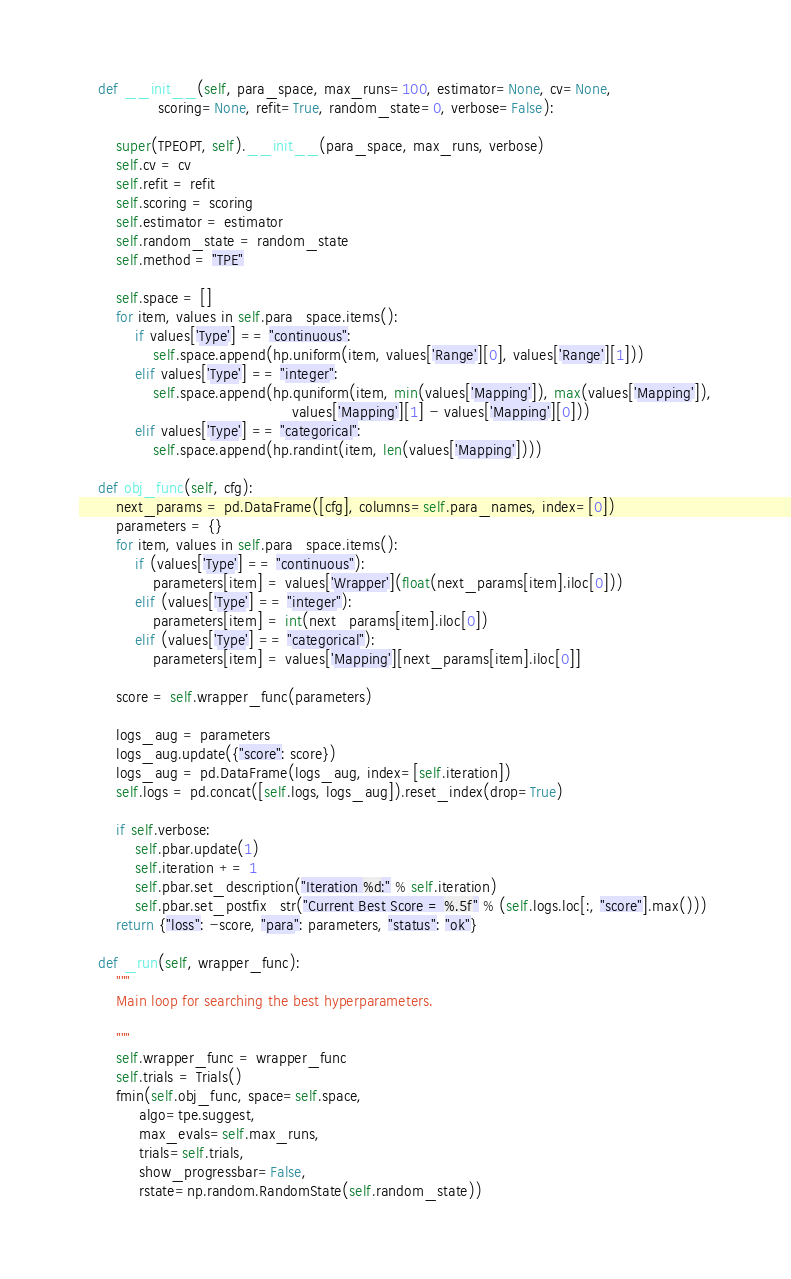Convert code to text. <code><loc_0><loc_0><loc_500><loc_500><_Python_>
    def __init__(self, para_space, max_runs=100, estimator=None, cv=None,
                 scoring=None, refit=True, random_state=0, verbose=False):

        super(TPEOPT, self).__init__(para_space, max_runs, verbose)
        self.cv = cv
        self.refit = refit
        self.scoring = scoring
        self.estimator = estimator
        self.random_state = random_state
        self.method = "TPE"

        self.space = []
        for item, values in self.para_space.items():
            if values['Type'] == "continuous":
                self.space.append(hp.uniform(item, values['Range'][0], values['Range'][1]))
            elif values['Type'] == "integer":
                self.space.append(hp.quniform(item, min(values['Mapping']), max(values['Mapping']),
                                              values['Mapping'][1] - values['Mapping'][0]))
            elif values['Type'] == "categorical":
                self.space.append(hp.randint(item, len(values['Mapping'])))

    def obj_func(self, cfg):
        next_params = pd.DataFrame([cfg], columns=self.para_names, index=[0])
        parameters = {}
        for item, values in self.para_space.items():
            if (values['Type'] == "continuous"):
                parameters[item] = values['Wrapper'](float(next_params[item].iloc[0]))
            elif (values['Type'] == "integer"):
                parameters[item] = int(next_params[item].iloc[0])
            elif (values['Type'] == "categorical"):
                parameters[item] = values['Mapping'][next_params[item].iloc[0]]

        score = self.wrapper_func(parameters)

        logs_aug = parameters
        logs_aug.update({"score": score})
        logs_aug = pd.DataFrame(logs_aug, index=[self.iteration])
        self.logs = pd.concat([self.logs, logs_aug]).reset_index(drop=True)

        if self.verbose:
            self.pbar.update(1)
            self.iteration += 1
            self.pbar.set_description("Iteration %d:" % self.iteration)
            self.pbar.set_postfix_str("Current Best Score = %.5f" % (self.logs.loc[:, "score"].max()))
        return {"loss": -score, "para": parameters, "status": "ok"}

    def _run(self, wrapper_func):
        """
        Main loop for searching the best hyperparameters.

        """
        self.wrapper_func = wrapper_func
        self.trials = Trials()
        fmin(self.obj_func, space=self.space,
             algo=tpe.suggest,
             max_evals=self.max_runs,
             trials=self.trials,
             show_progressbar=False,
             rstate=np.random.RandomState(self.random_state))
</code> 